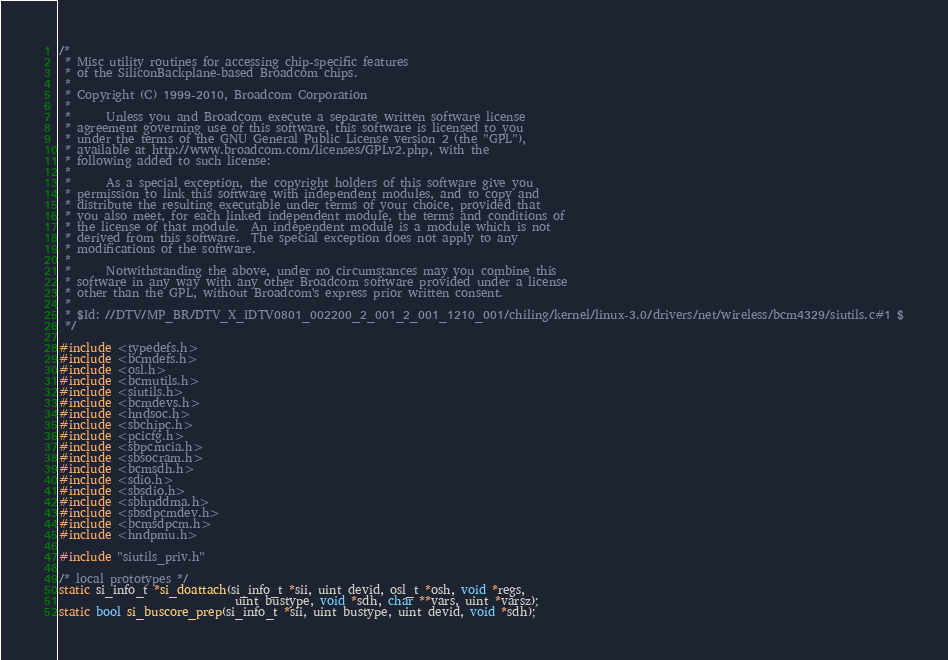<code> <loc_0><loc_0><loc_500><loc_500><_C_>/*
 * Misc utility routines for accessing chip-specific features
 * of the SiliconBackplane-based Broadcom chips.
 *
 * Copyright (C) 1999-2010, Broadcom Corporation
 * 
 *      Unless you and Broadcom execute a separate written software license
 * agreement governing use of this software, this software is licensed to you
 * under the terms of the GNU General Public License version 2 (the "GPL"),
 * available at http://www.broadcom.com/licenses/GPLv2.php, with the
 * following added to such license:
 * 
 *      As a special exception, the copyright holders of this software give you
 * permission to link this software with independent modules, and to copy and
 * distribute the resulting executable under terms of your choice, provided that
 * you also meet, for each linked independent module, the terms and conditions of
 * the license of that module.  An independent module is a module which is not
 * derived from this software.  The special exception does not apply to any
 * modifications of the software.
 * 
 *      Notwithstanding the above, under no circumstances may you combine this
 * software in any way with any other Broadcom software provided under a license
 * other than the GPL, without Broadcom's express prior written consent.
 *
 * $Id: //DTV/MP_BR/DTV_X_IDTV0801_002200_2_001_2_001_1210_001/chiling/kernel/linux-3.0/drivers/net/wireless/bcm4329/siutils.c#1 $
 */

#include <typedefs.h>
#include <bcmdefs.h>
#include <osl.h>
#include <bcmutils.h>
#include <siutils.h>
#include <bcmdevs.h>
#include <hndsoc.h>
#include <sbchipc.h>
#include <pcicfg.h>
#include <sbpcmcia.h>
#include <sbsocram.h>
#include <bcmsdh.h>
#include <sdio.h>
#include <sbsdio.h>
#include <sbhnddma.h>
#include <sbsdpcmdev.h>
#include <bcmsdpcm.h>
#include <hndpmu.h>

#include "siutils_priv.h"

/* local prototypes */
static si_info_t *si_doattach(si_info_t *sii, uint devid, osl_t *osh, void *regs,
                              uint bustype, void *sdh, char **vars, uint *varsz);
static bool si_buscore_prep(si_info_t *sii, uint bustype, uint devid, void *sdh);</code> 